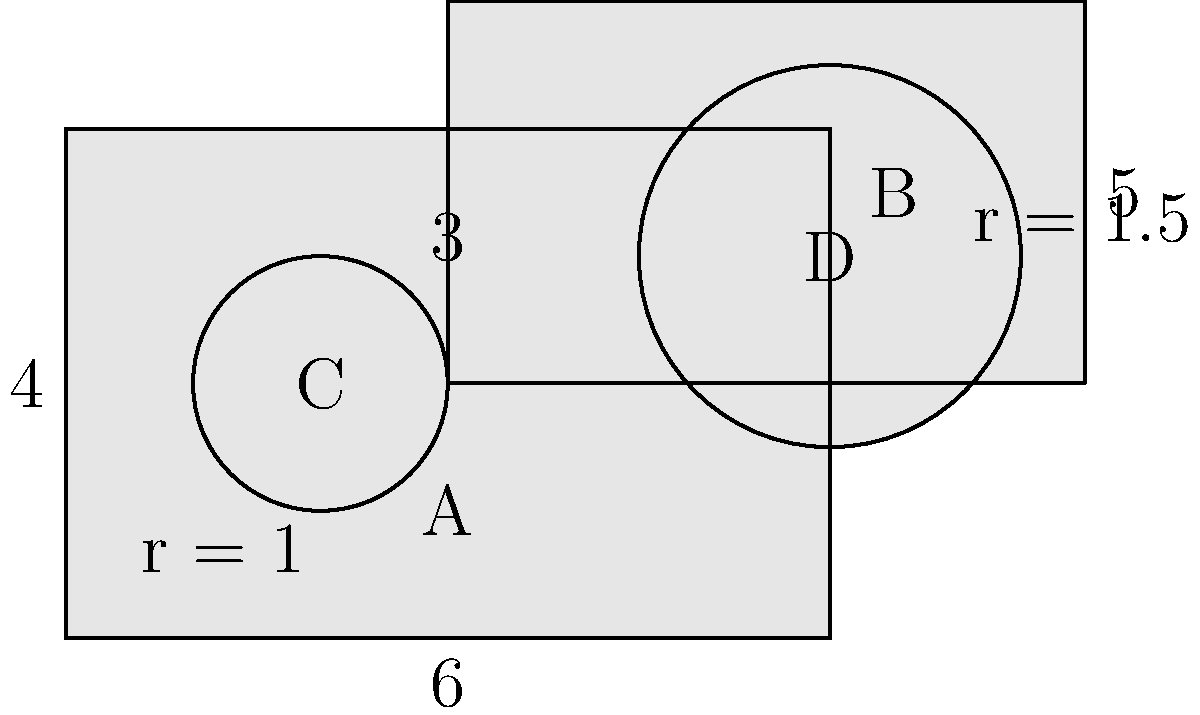In the composite shape above, rectangle A measures 6 units by 4 units, and rectangle B measures 5 units by 3 units. Circle C has a radius of 1 unit, and circle D has a radius of 1.5 units. Calculate the total area of the shaded region. To find the total area of the shaded region, we need to:

1. Calculate the areas of individual shapes:
   Rectangle A: $A_A = 6 \times 4 = 24$ sq units
   Rectangle B: $A_B = 5 \times 3 = 15$ sq units
   Circle C: $A_C = \pi r^2 = \pi (1)^2 = \pi$ sq units
   Circle D: $A_D = \pi r^2 = \pi (1.5)^2 = 2.25\pi$ sq units

2. Identify overlapping regions:
   - Rectangle A and B overlap
   - Circle C is entirely within Rectangle A
   - Circle D overlaps both Rectangle A and B

3. Calculate the area of overlapping regions:
   Rectangles A and B: $3 \times 2 = 6$ sq units
   Circle D in Rectangle A: $\frac{1}{2} \times 2.25\pi = 1.125\pi$ sq units
   Circle D in Rectangle B: $2.25\pi - 1.125\pi = 1.125\pi$ sq units

4. Sum up the areas and subtract overlaps:
   Total Area = $A_A + A_B + A_D - \text{Overlap(A,B)} - A_C - \text{Overlap(D,A)} - \text{Overlap(D,B)}$
   $= 24 + 15 + 2.25\pi - 6 - \pi - 1.125\pi - 1.125\pi$
   $= 33 + 2.25\pi - 6 - 3.25\pi$
   $= 27 - \pi$

Therefore, the total area of the shaded region is $27 - \pi$ square units.
Answer: $27 - \pi$ sq units 